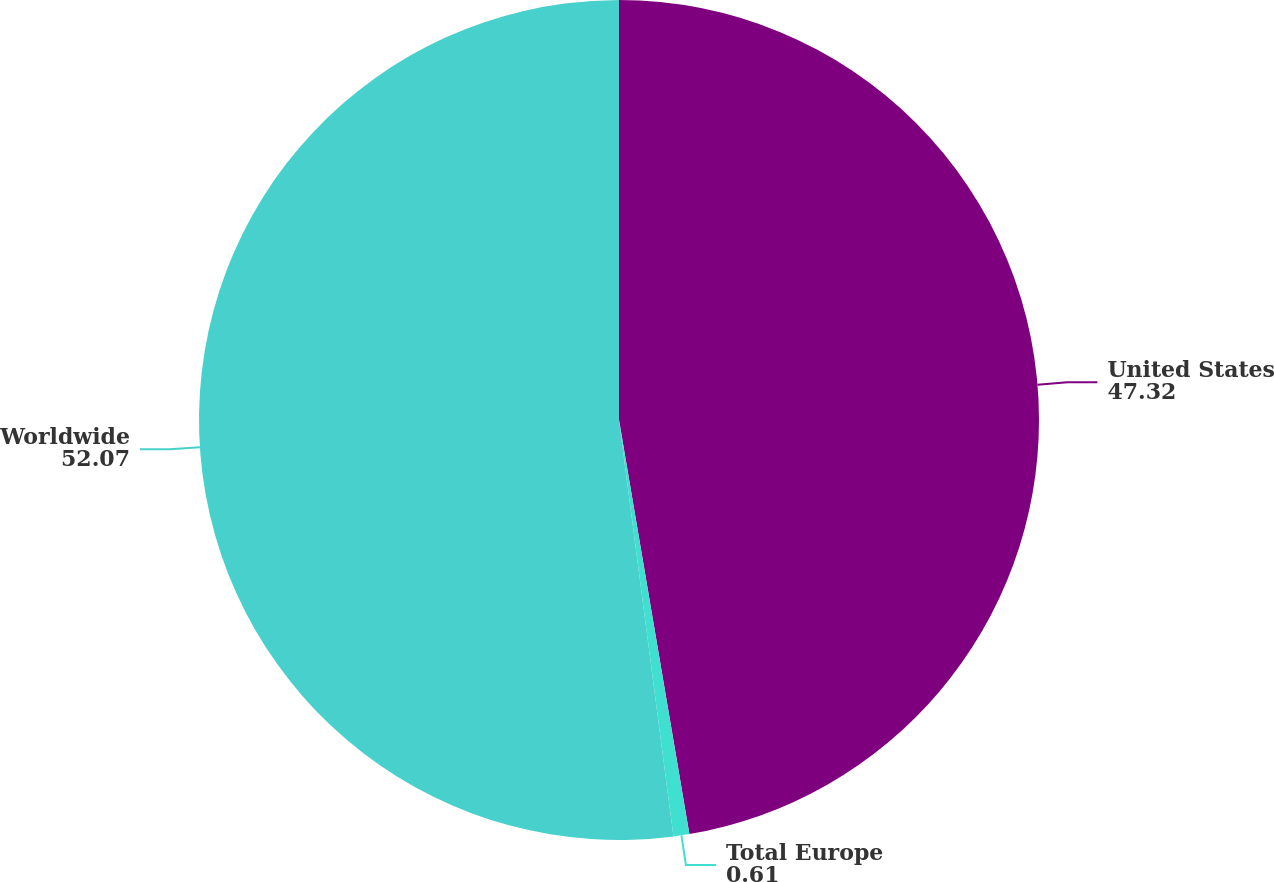Convert chart to OTSL. <chart><loc_0><loc_0><loc_500><loc_500><pie_chart><fcel>United States<fcel>Total Europe<fcel>Worldwide<nl><fcel>47.32%<fcel>0.61%<fcel>52.07%<nl></chart> 